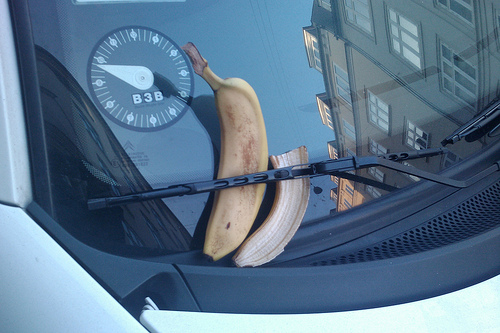<image>
Is the banana on the windshield? Yes. Looking at the image, I can see the banana is positioned on top of the windshield, with the windshield providing support. Where is the windshield in relation to the banana? Is it on the banana? No. The windshield is not positioned on the banana. They may be near each other, but the windshield is not supported by or resting on top of the banana. 